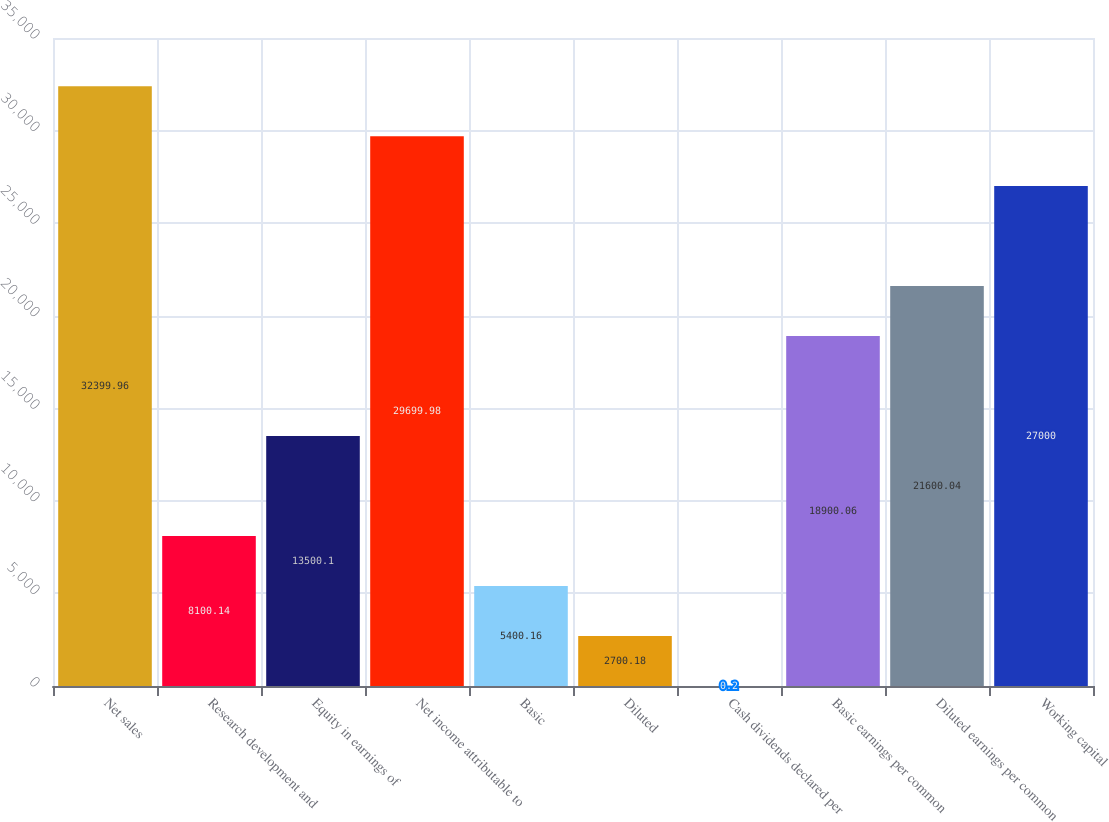<chart> <loc_0><loc_0><loc_500><loc_500><bar_chart><fcel>Net sales<fcel>Research development and<fcel>Equity in earnings of<fcel>Net income attributable to<fcel>Basic<fcel>Diluted<fcel>Cash dividends declared per<fcel>Basic earnings per common<fcel>Diluted earnings per common<fcel>Working capital<nl><fcel>32400<fcel>8100.14<fcel>13500.1<fcel>29700<fcel>5400.16<fcel>2700.18<fcel>0.2<fcel>18900.1<fcel>21600<fcel>27000<nl></chart> 